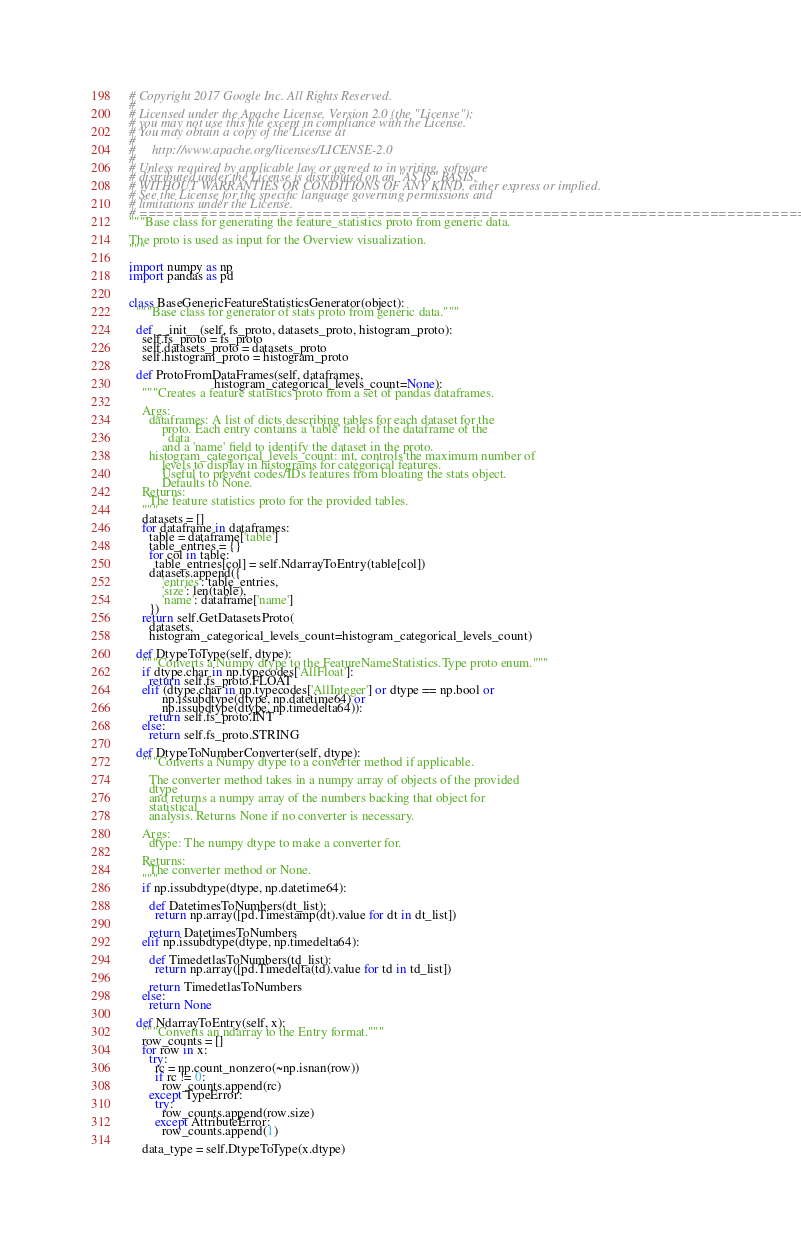<code> <loc_0><loc_0><loc_500><loc_500><_Python_># Copyright 2017 Google Inc. All Rights Reserved.
#
# Licensed under the Apache License, Version 2.0 (the "License");
# you may not use this file except in compliance with the License.
# You may obtain a copy of the License at
#
#     http://www.apache.org/licenses/LICENSE-2.0
#
# Unless required by applicable law or agreed to in writing, software
# distributed under the License is distributed on an "AS IS" BASIS,
# WITHOUT WARRANTIES OR CONDITIONS OF ANY KIND, either express or implied.
# See the License for the specific language governing permissions and
# limitations under the License.
# ==============================================================================
"""Base class for generating the feature_statistics proto from generic data.

The proto is used as input for the Overview visualization.
"""

import numpy as np
import pandas as pd


class BaseGenericFeatureStatisticsGenerator(object):
  """Base class for generator of stats proto from generic data."""

  def __init__(self, fs_proto, datasets_proto, histogram_proto):
    self.fs_proto = fs_proto
    self.datasets_proto = datasets_proto
    self.histogram_proto = histogram_proto

  def ProtoFromDataFrames(self, dataframes,
                          histogram_categorical_levels_count=None):
    """Creates a feature statistics proto from a set of pandas dataframes.

    Args:
      dataframes: A list of dicts describing tables for each dataset for the
          proto. Each entry contains a 'table' field of the dataframe of the
            data
          and a 'name' field to identify the dataset in the proto.
      histogram_categorical_levels_count: int, controls the maximum number of
          levels to display in histograms for categorical features.
          Useful to prevent codes/IDs features from bloating the stats object.
          Defaults to None.
    Returns:
      The feature statistics proto for the provided tables.
    """
    datasets = []
    for dataframe in dataframes:
      table = dataframe['table']
      table_entries = {}
      for col in table:
        table_entries[col] = self.NdarrayToEntry(table[col])
      datasets.append({
          'entries': table_entries,
          'size': len(table),
          'name': dataframe['name']
      })
    return self.GetDatasetsProto(
      datasets,
      histogram_categorical_levels_count=histogram_categorical_levels_count)

  def DtypeToType(self, dtype):
    """Converts a Numpy dtype to the FeatureNameStatistics.Type proto enum."""
    if dtype.char in np.typecodes['AllFloat']:
      return self.fs_proto.FLOAT
    elif (dtype.char in np.typecodes['AllInteger'] or dtype == np.bool or
          np.issubdtype(dtype, np.datetime64) or
          np.issubdtype(dtype, np.timedelta64)):
      return self.fs_proto.INT
    else:
      return self.fs_proto.STRING

  def DtypeToNumberConverter(self, dtype):
    """Converts a Numpy dtype to a converter method if applicable.

      The converter method takes in a numpy array of objects of the provided
      dtype
      and returns a numpy array of the numbers backing that object for
      statistical
      analysis. Returns None if no converter is necessary.

    Args:
      dtype: The numpy dtype to make a converter for.

    Returns:
      The converter method or None.
    """
    if np.issubdtype(dtype, np.datetime64):

      def DatetimesToNumbers(dt_list):
        return np.array([pd.Timestamp(dt).value for dt in dt_list])

      return DatetimesToNumbers
    elif np.issubdtype(dtype, np.timedelta64):

      def TimedetlasToNumbers(td_list):
        return np.array([pd.Timedelta(td).value for td in td_list])

      return TimedetlasToNumbers
    else:
      return None

  def NdarrayToEntry(self, x):
    """Converts an ndarray to the Entry format."""
    row_counts = []
    for row in x:
      try:
        rc = np.count_nonzero(~np.isnan(row))
        if rc != 0:
          row_counts.append(rc)
      except TypeError:
        try:
          row_counts.append(row.size)
        except AttributeError:
          row_counts.append(1)

    data_type = self.DtypeToType(x.dtype)</code> 